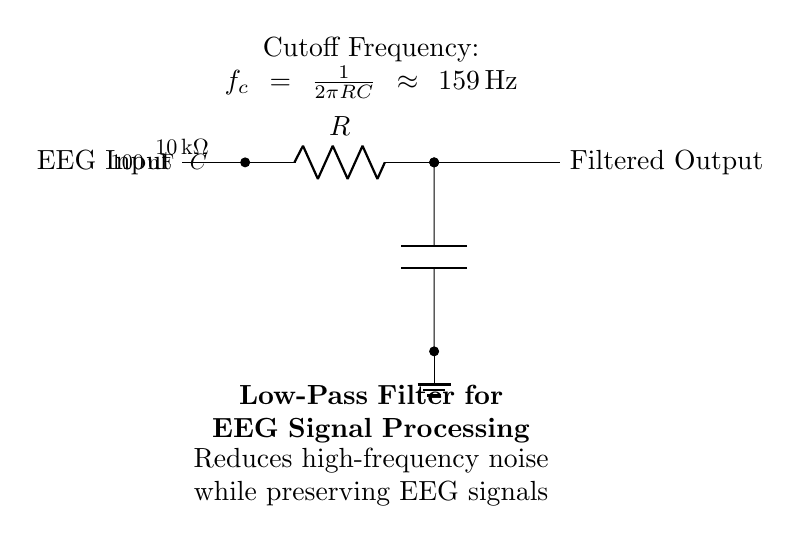What is the component placed directly after the EEG Input? The component directly after the EEG Input is a resistor. It is the first component in the chain that processes the input signal.
Answer: resistor What is the resistance value of the resistor in this circuit? The resistance value is specified as ten kilo-ohms. It is indicated in the circuit diagram next to the resistor symbol.
Answer: ten kilo-ohms How does the capacitor in this circuit affect the signal? The capacitor acts to block high-frequency signals while allowing lower frequency signals to pass through, thus filtering out noise from the EEG data. This is a key function of low-pass filters.
Answer: reduces high-frequency noise What is the cutoff frequency of this low-pass filter? The cutoff frequency is calculated using the formula one over two pi times the resistance times the capacitance, yielding approximately one hundred fifty-nine hertz.
Answer: one hundred fifty-nine hertz What type of filter is depicted in the circuit? The filter depicted is a low-pass filter. This specifically describes its operation of allowing low frequencies to pass while attenuating high frequencies.
Answer: low-pass filter What is the purpose of this circuit in EEG signal processing? The purpose of this circuit is to reduce high-frequency noise while preserving the desired EEG signals, which are typically low frequency. This is critical for obtaining clean and usable EEG data.
Answer: reduce high-frequency noise 